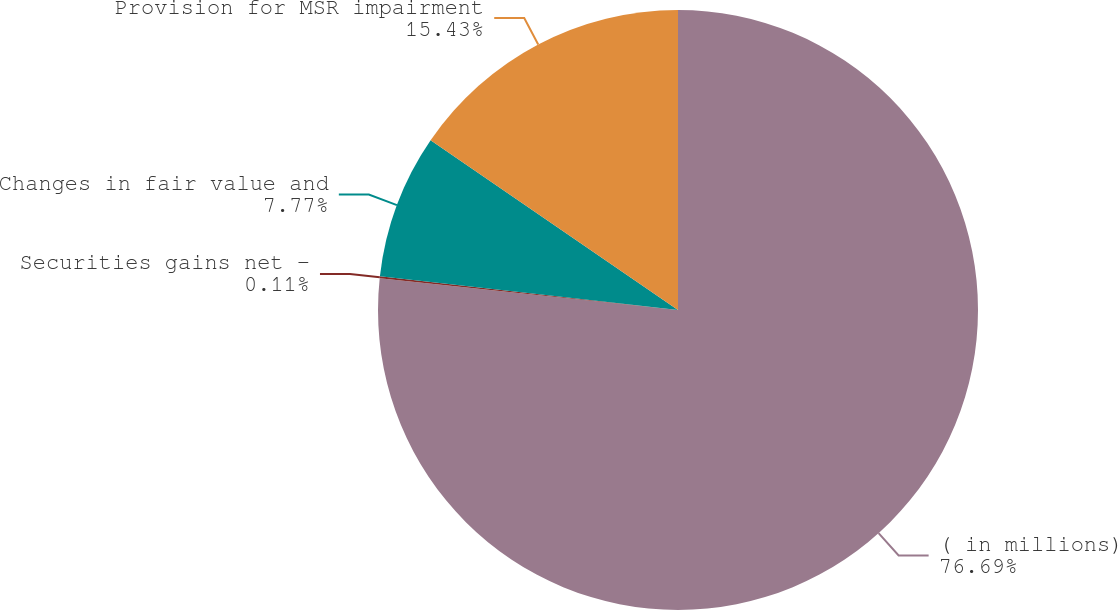Convert chart to OTSL. <chart><loc_0><loc_0><loc_500><loc_500><pie_chart><fcel>( in millions)<fcel>Securities gains net -<fcel>Changes in fair value and<fcel>Provision for MSR impairment<nl><fcel>76.69%<fcel>0.11%<fcel>7.77%<fcel>15.43%<nl></chart> 